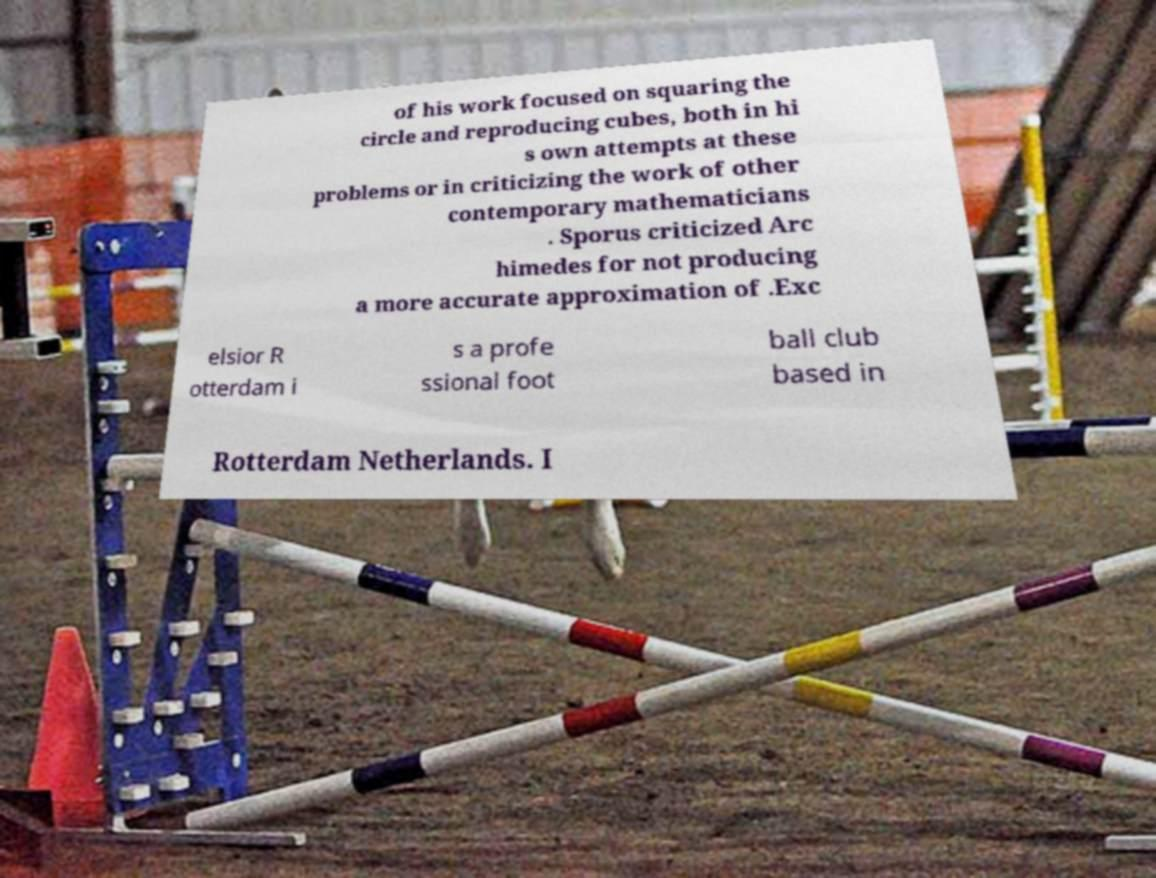What messages or text are displayed in this image? I need them in a readable, typed format. of his work focused on squaring the circle and reproducing cubes, both in hi s own attempts at these problems or in criticizing the work of other contemporary mathematicians . Sporus criticized Arc himedes for not producing a more accurate approximation of .Exc elsior R otterdam i s a profe ssional foot ball club based in Rotterdam Netherlands. I 